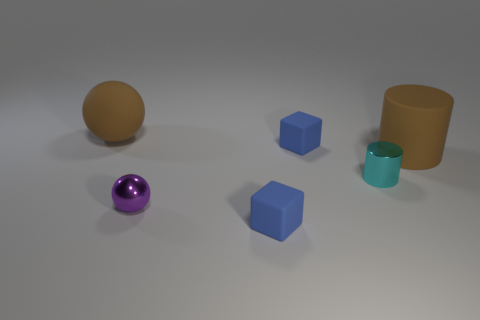What size is the rubber thing that is the same color as the large rubber cylinder?
Offer a very short reply. Large. What number of objects are either brown spheres or rubber things that are in front of the large rubber sphere?
Keep it short and to the point. 4. Are there any big rubber objects of the same color as the large ball?
Provide a succinct answer. Yes. What number of blue things are either rubber cylinders or rubber blocks?
Make the answer very short. 2. How many other things are there of the same size as the brown matte ball?
Give a very brief answer. 1. How many large objects are cyan cylinders or brown objects?
Offer a terse response. 2. Is the size of the purple ball the same as the blue matte block behind the small cyan metal cylinder?
Keep it short and to the point. Yes. What number of other things are the same shape as the small cyan shiny thing?
Offer a very short reply. 1. What shape is the tiny purple object that is made of the same material as the small cylinder?
Your response must be concise. Sphere. Is there a tiny cyan cylinder?
Keep it short and to the point. Yes. 